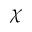<formula> <loc_0><loc_0><loc_500><loc_500>\chi</formula> 